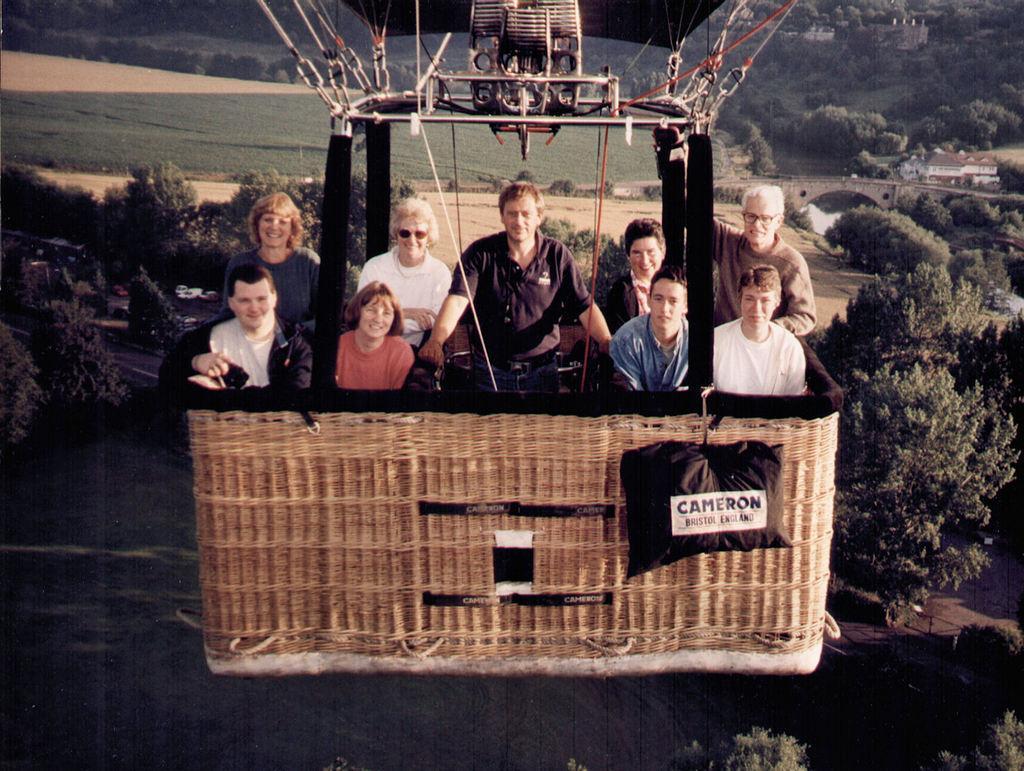Can you describe this image briefly? In this picture, we see people are on the ropeway. All of them are smiling. On either side of the picture, we see trees. There are trees and hills in the background. 